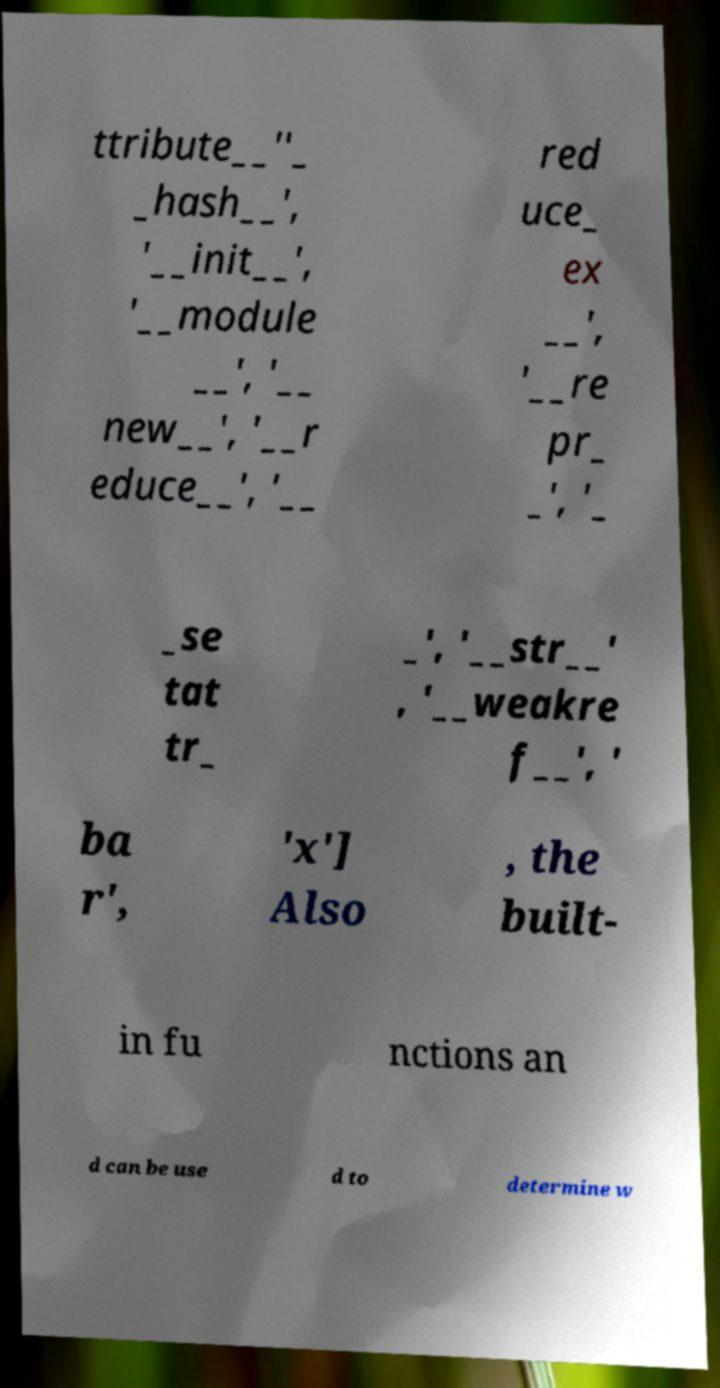There's text embedded in this image that I need extracted. Can you transcribe it verbatim? ttribute__''_ _hash__', '__init__', '__module __', '__ new__', '__r educe__', '__ red uce_ ex __', '__re pr_ _', '_ _se tat tr_ _', '__str__' , '__weakre f__', ' ba r', 'x'] Also , the built- in fu nctions an d can be use d to determine w 